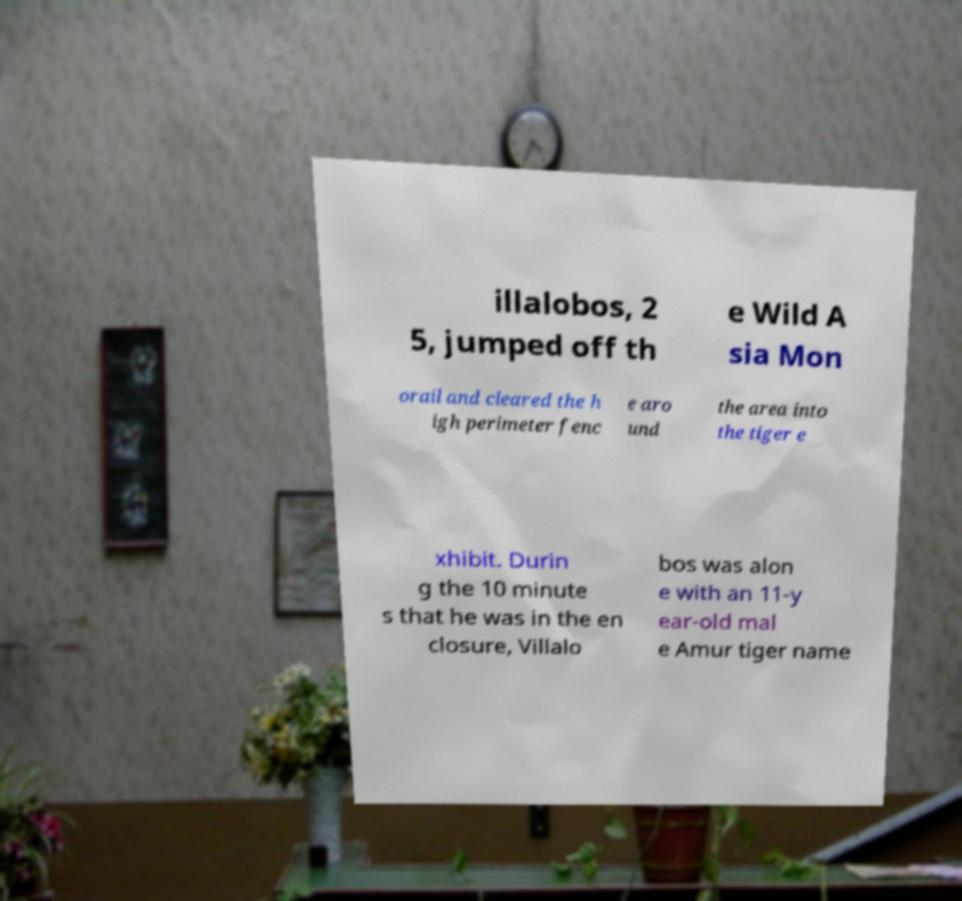Please read and relay the text visible in this image. What does it say? illalobos, 2 5, jumped off th e Wild A sia Mon orail and cleared the h igh perimeter fenc e aro und the area into the tiger e xhibit. Durin g the 10 minute s that he was in the en closure, Villalo bos was alon e with an 11-y ear-old mal e Amur tiger name 